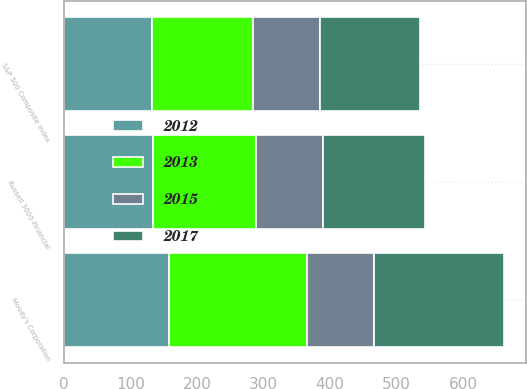Convert chart. <chart><loc_0><loc_0><loc_500><loc_500><stacked_bar_chart><ecel><fcel>Moody's Corporation<fcel>S&P 500 Composite Index<fcel>Russell 3000-Financial<nl><fcel>2015<fcel>100<fcel>100<fcel>100<nl><fcel>2012<fcel>158.22<fcel>132.39<fcel>134.63<nl><fcel>2017<fcel>195.66<fcel>150.51<fcel>153.55<nl><fcel>2013<fcel>207.57<fcel>152.59<fcel>154.32<nl></chart> 